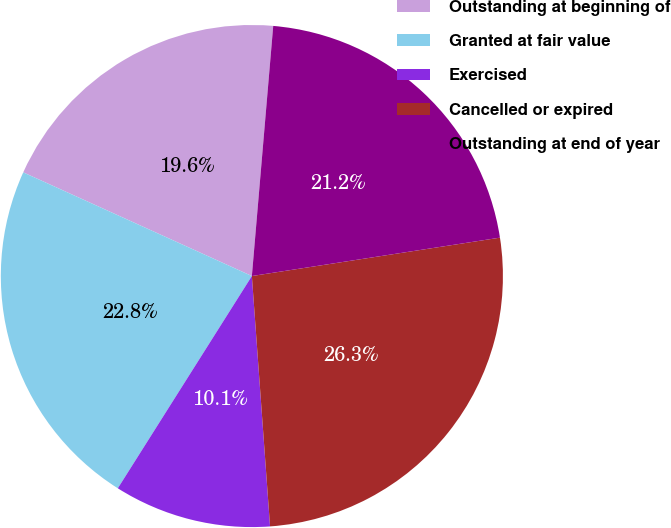<chart> <loc_0><loc_0><loc_500><loc_500><pie_chart><fcel>Outstanding at beginning of<fcel>Granted at fair value<fcel>Exercised<fcel>Cancelled or expired<fcel>Outstanding at end of year<nl><fcel>19.58%<fcel>22.81%<fcel>10.12%<fcel>26.29%<fcel>21.2%<nl></chart> 